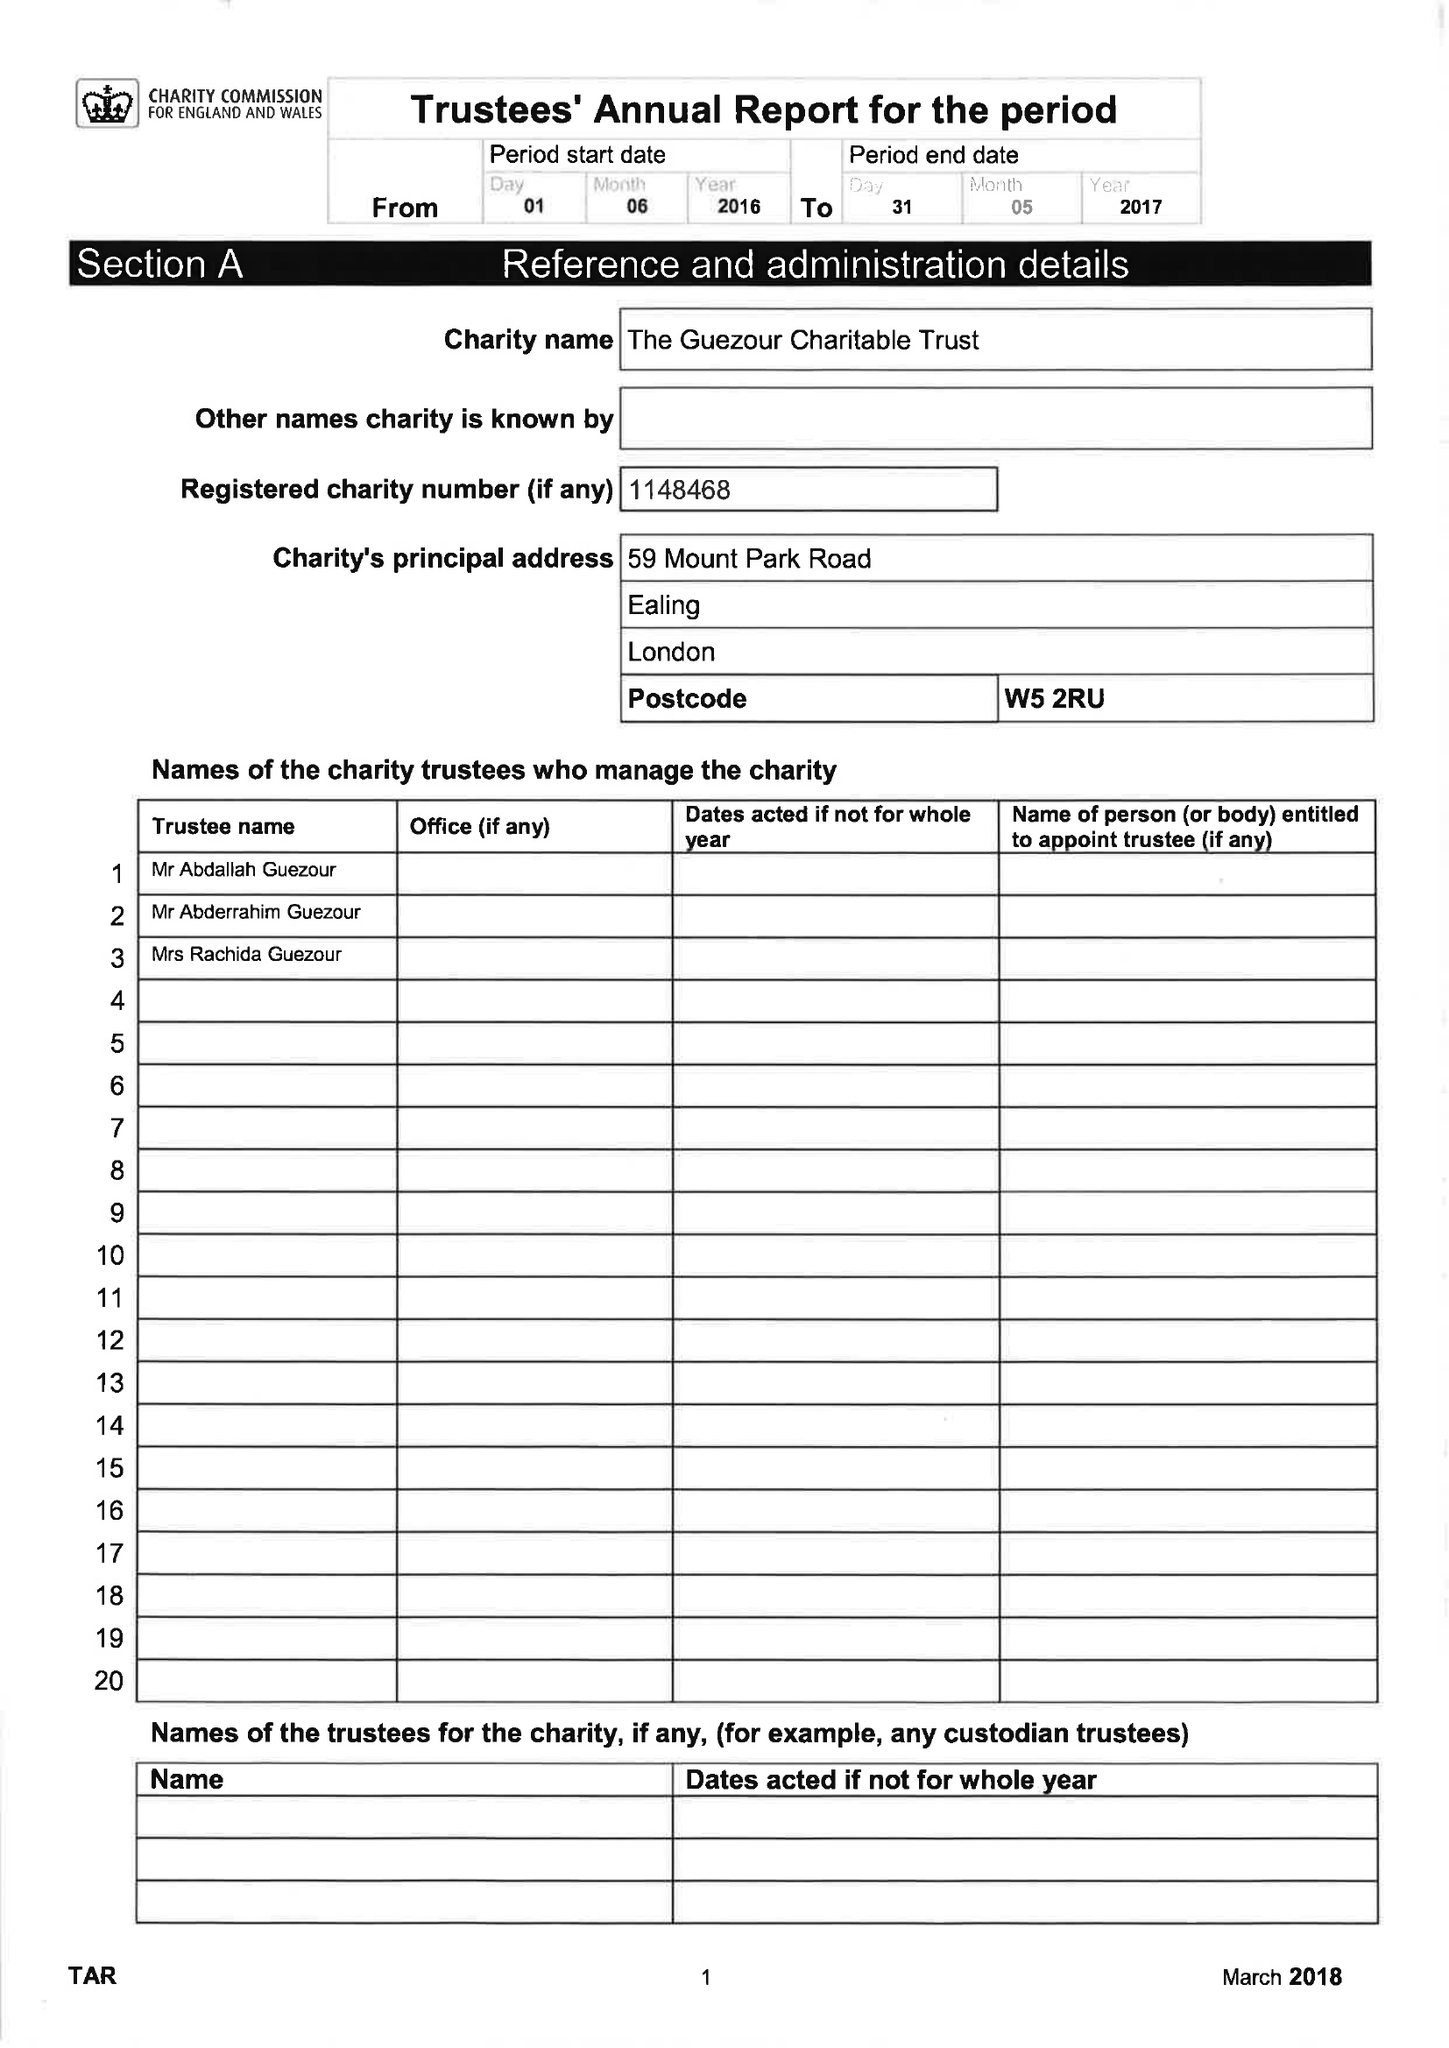What is the value for the charity_number?
Answer the question using a single word or phrase. 1148468 